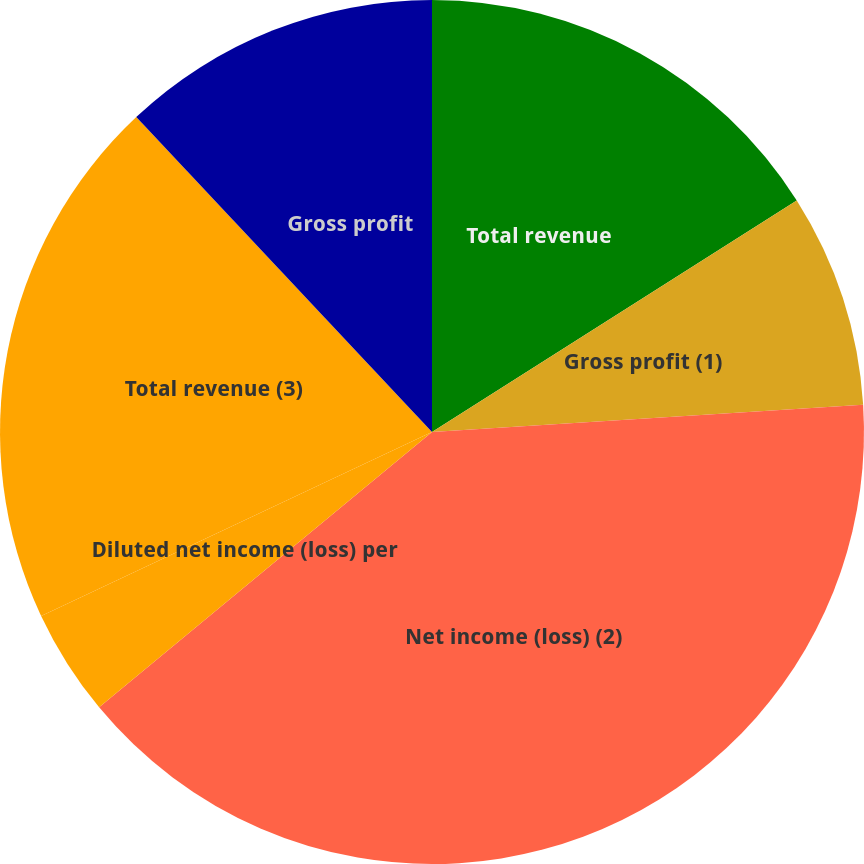Convert chart. <chart><loc_0><loc_0><loc_500><loc_500><pie_chart><fcel>Total revenue<fcel>Gross profit (1)<fcel>Net income (loss) (2)<fcel>Diluted net income (loss) per<fcel>Total revenue (3)<fcel>Gross profit<fcel>Diluted net income(loss) per<nl><fcel>16.0%<fcel>8.0%<fcel>40.0%<fcel>4.0%<fcel>20.0%<fcel>12.0%<fcel>0.0%<nl></chart> 